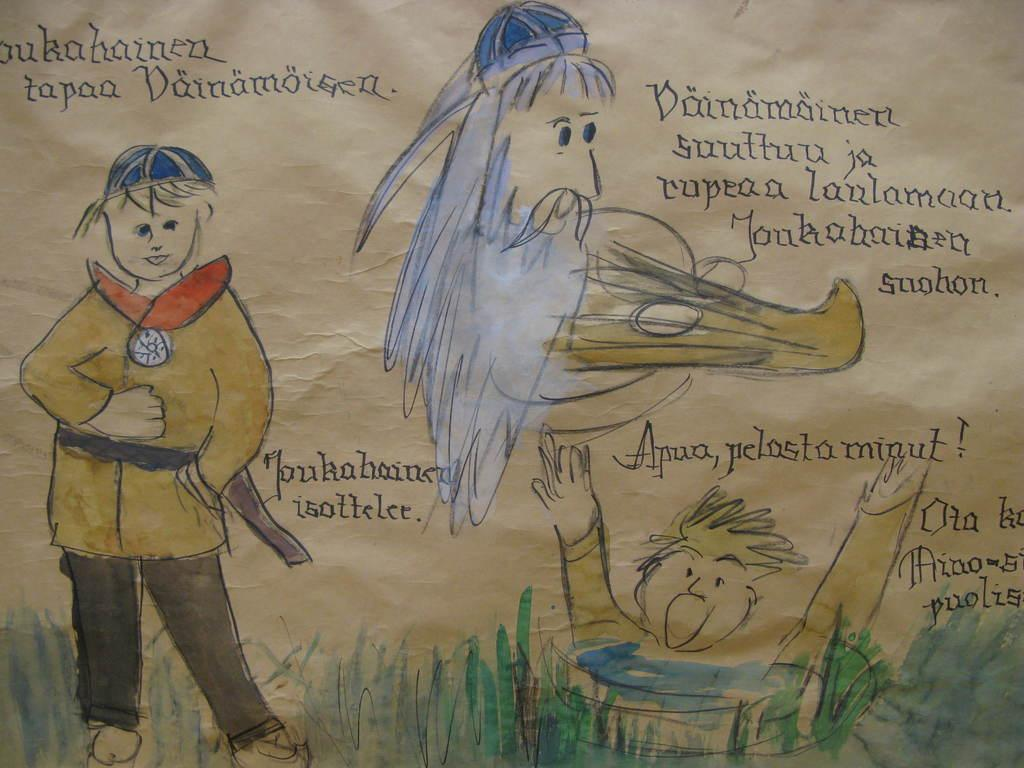What medium is used for the artwork in the image? The image is a painting on a paper. Is there any text present in the image? Yes, there is writing on the paper. What is depicted on the left side of the paper? There is a painting of a child on the left side of the paper. How does the pollution affect the river in the image? There is no river or pollution present in the image; it is a painting of a child on a paper with writing. What type of joke is being told by the child in the image? There is no joke being told by the child in the image; it is a painting of a child on a paper with writing. 